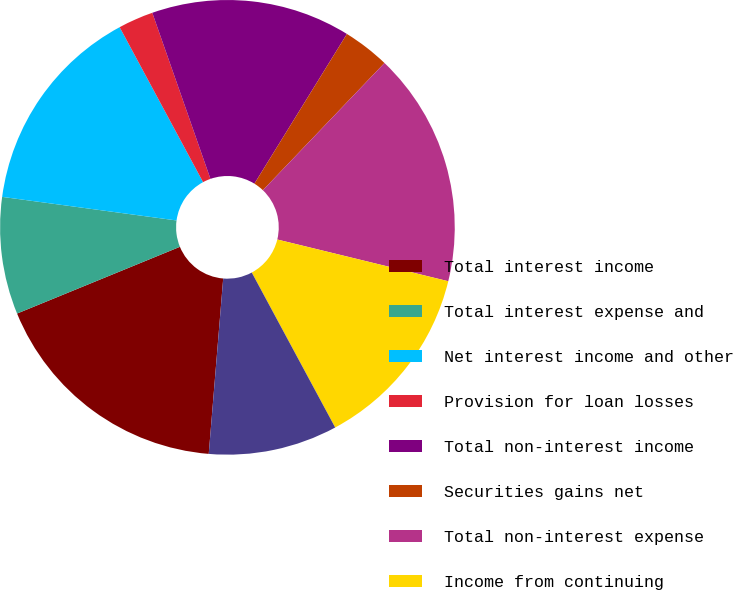<chart> <loc_0><loc_0><loc_500><loc_500><pie_chart><fcel>Total interest income<fcel>Total interest expense and<fcel>Net interest income and other<fcel>Provision for loan losses<fcel>Total non-interest income<fcel>Securities gains net<fcel>Total non-interest expense<fcel>Income from continuing<fcel>Income tax expense<nl><fcel>17.5%<fcel>8.33%<fcel>15.0%<fcel>2.5%<fcel>14.17%<fcel>3.33%<fcel>16.67%<fcel>13.33%<fcel>9.17%<nl></chart> 